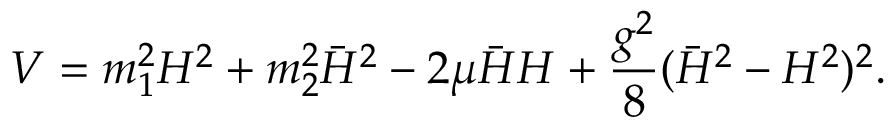Convert formula to latex. <formula><loc_0><loc_0><loc_500><loc_500>V = m _ { 1 } ^ { 2 } H ^ { 2 } + m _ { 2 } ^ { 2 } \bar { H } ^ { 2 } - 2 \mu \bar { H } H + \frac { g ^ { 2 } } { 8 } ( \bar { H } ^ { 2 } - H ^ { 2 } ) ^ { 2 } .</formula> 